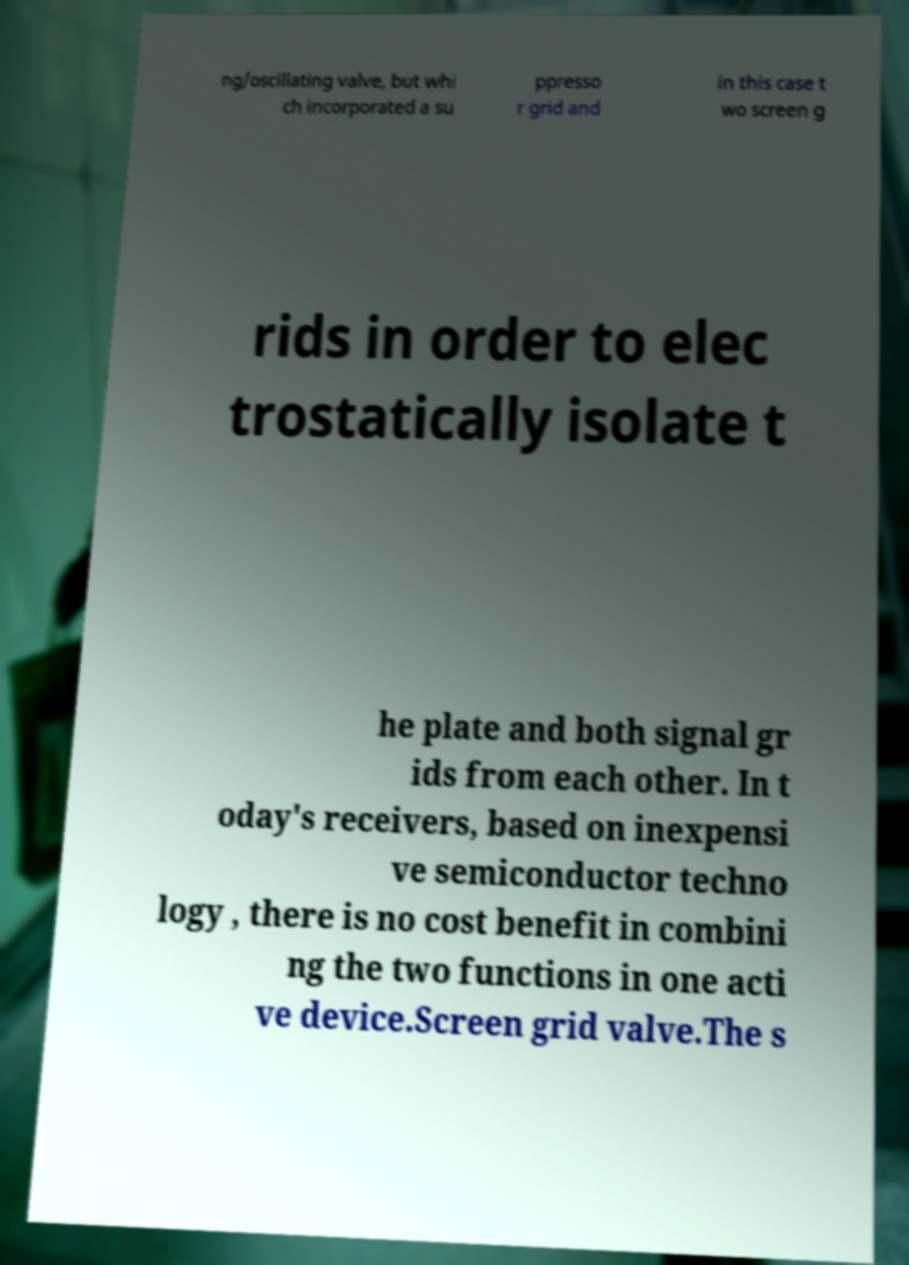Could you assist in decoding the text presented in this image and type it out clearly? ng/oscillating valve, but whi ch incorporated a su ppresso r grid and in this case t wo screen g rids in order to elec trostatically isolate t he plate and both signal gr ids from each other. In t oday's receivers, based on inexpensi ve semiconductor techno logy , there is no cost benefit in combini ng the two functions in one acti ve device.Screen grid valve.The s 